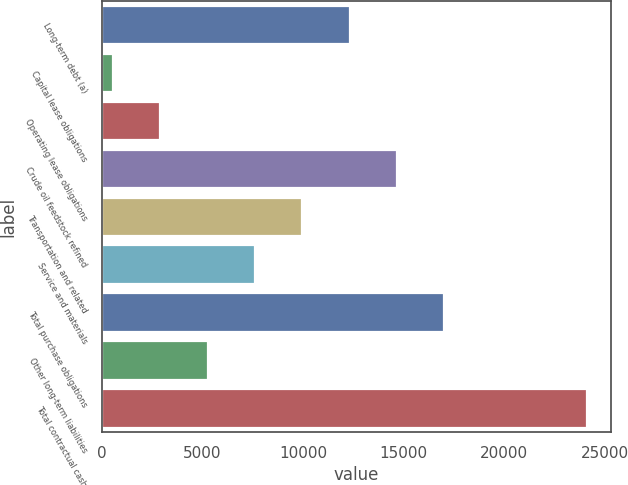<chart> <loc_0><loc_0><loc_500><loc_500><bar_chart><fcel>Long-term debt (a)<fcel>Capital lease obligations<fcel>Operating lease obligations<fcel>Crude oil feedstock refined<fcel>Transportation and related<fcel>Service and materials<fcel>Total purchase obligations<fcel>Other long-term liabilities<fcel>Total contractual cash<nl><fcel>12317<fcel>546<fcel>2900.2<fcel>14671.2<fcel>9962.8<fcel>7608.6<fcel>17025.4<fcel>5254.4<fcel>24088<nl></chart> 